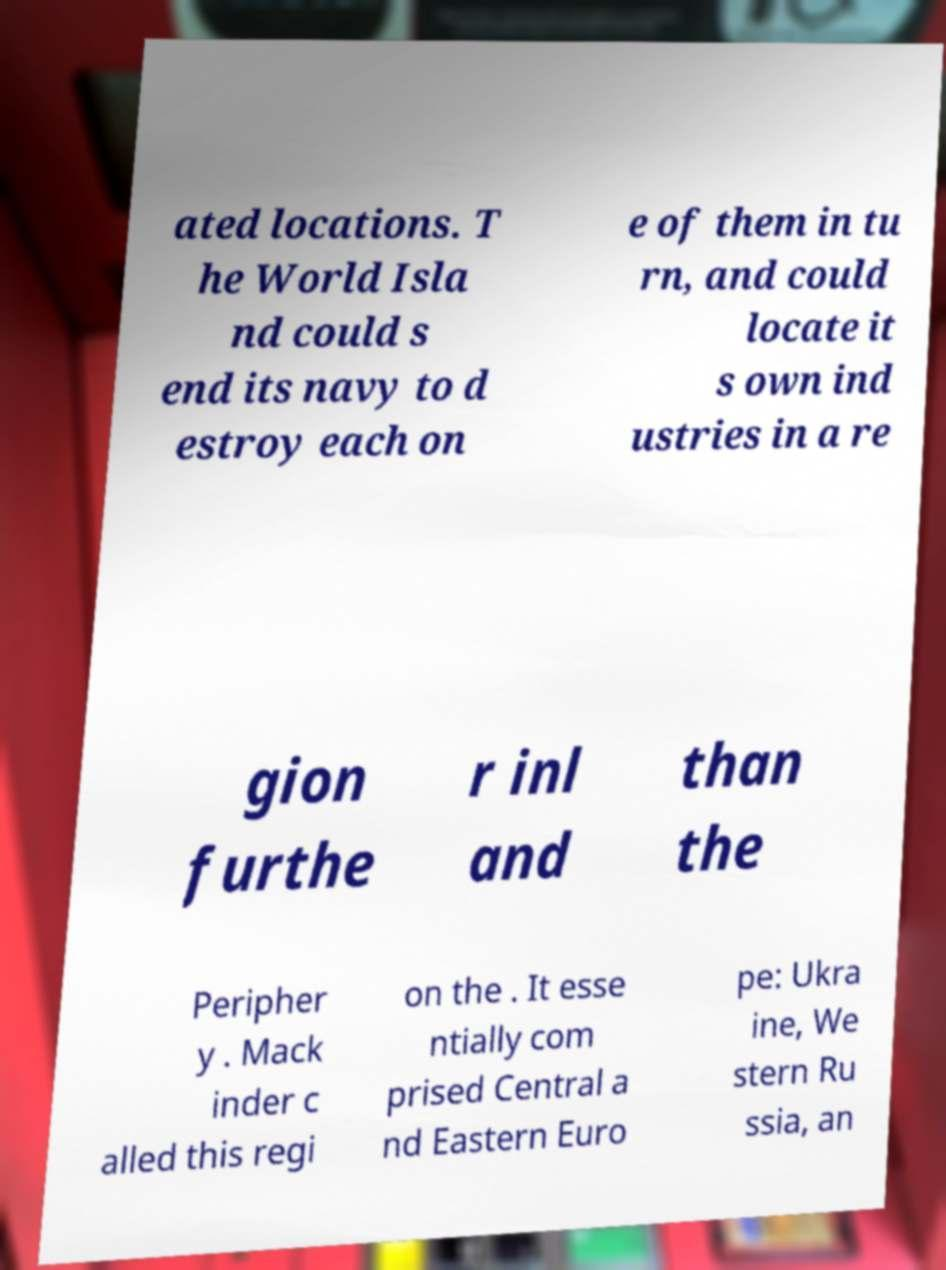I need the written content from this picture converted into text. Can you do that? ated locations. T he World Isla nd could s end its navy to d estroy each on e of them in tu rn, and could locate it s own ind ustries in a re gion furthe r inl and than the Peripher y . Mack inder c alled this regi on the . It esse ntially com prised Central a nd Eastern Euro pe: Ukra ine, We stern Ru ssia, an 